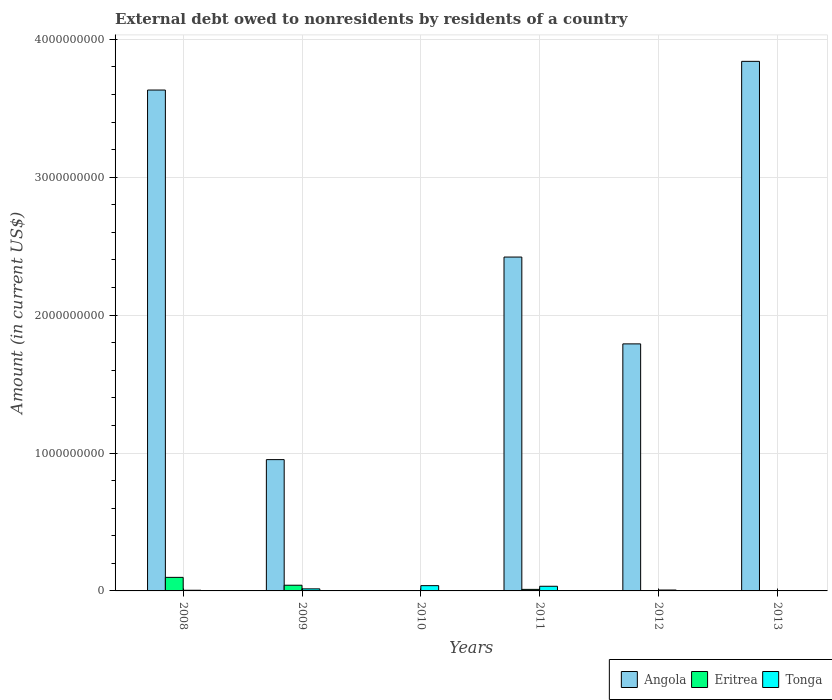Are the number of bars per tick equal to the number of legend labels?
Provide a succinct answer. No. Are the number of bars on each tick of the X-axis equal?
Give a very brief answer. No. How many bars are there on the 3rd tick from the right?
Provide a short and direct response. 3. What is the external debt owed by residents in Eritrea in 2008?
Keep it short and to the point. 9.83e+07. Across all years, what is the maximum external debt owed by residents in Tonga?
Keep it short and to the point. 3.82e+07. Across all years, what is the minimum external debt owed by residents in Tonga?
Keep it short and to the point. 0. In which year was the external debt owed by residents in Eritrea maximum?
Provide a succinct answer. 2008. What is the total external debt owed by residents in Eritrea in the graph?
Provide a succinct answer. 1.51e+08. What is the difference between the external debt owed by residents in Eritrea in 2009 and that in 2011?
Ensure brevity in your answer.  3.02e+07. What is the difference between the external debt owed by residents in Eritrea in 2012 and the external debt owed by residents in Angola in 2013?
Make the answer very short. -3.84e+09. What is the average external debt owed by residents in Angola per year?
Offer a very short reply. 2.11e+09. In the year 2008, what is the difference between the external debt owed by residents in Angola and external debt owed by residents in Eritrea?
Give a very brief answer. 3.53e+09. In how many years, is the external debt owed by residents in Tonga greater than 2000000000 US$?
Offer a terse response. 0. What is the ratio of the external debt owed by residents in Angola in 2009 to that in 2013?
Make the answer very short. 0.25. Is the external debt owed by residents in Tonga in 2009 less than that in 2011?
Your response must be concise. Yes. What is the difference between the highest and the second highest external debt owed by residents in Tonga?
Provide a short and direct response. 4.60e+06. What is the difference between the highest and the lowest external debt owed by residents in Eritrea?
Provide a succinct answer. 9.83e+07. In how many years, is the external debt owed by residents in Eritrea greater than the average external debt owed by residents in Eritrea taken over all years?
Offer a very short reply. 2. Is the sum of the external debt owed by residents in Tonga in 2010 and 2011 greater than the maximum external debt owed by residents in Angola across all years?
Ensure brevity in your answer.  No. Is it the case that in every year, the sum of the external debt owed by residents in Tonga and external debt owed by residents in Eritrea is greater than the external debt owed by residents in Angola?
Make the answer very short. No. How many bars are there?
Keep it short and to the point. 13. Are all the bars in the graph horizontal?
Your answer should be very brief. No. How many years are there in the graph?
Give a very brief answer. 6. How many legend labels are there?
Ensure brevity in your answer.  3. How are the legend labels stacked?
Provide a short and direct response. Horizontal. What is the title of the graph?
Offer a very short reply. External debt owed to nonresidents by residents of a country. Does "Armenia" appear as one of the legend labels in the graph?
Your answer should be compact. No. What is the label or title of the Y-axis?
Offer a terse response. Amount (in current US$). What is the Amount (in current US$) in Angola in 2008?
Keep it short and to the point. 3.63e+09. What is the Amount (in current US$) of Eritrea in 2008?
Ensure brevity in your answer.  9.83e+07. What is the Amount (in current US$) of Tonga in 2008?
Offer a terse response. 4.80e+06. What is the Amount (in current US$) in Angola in 2009?
Give a very brief answer. 9.52e+08. What is the Amount (in current US$) of Eritrea in 2009?
Ensure brevity in your answer.  4.13e+07. What is the Amount (in current US$) in Tonga in 2009?
Ensure brevity in your answer.  1.49e+07. What is the Amount (in current US$) of Angola in 2010?
Your answer should be compact. 0. What is the Amount (in current US$) in Eritrea in 2010?
Keep it short and to the point. 0. What is the Amount (in current US$) in Tonga in 2010?
Give a very brief answer. 3.82e+07. What is the Amount (in current US$) in Angola in 2011?
Keep it short and to the point. 2.42e+09. What is the Amount (in current US$) in Eritrea in 2011?
Give a very brief answer. 1.12e+07. What is the Amount (in current US$) of Tonga in 2011?
Offer a very short reply. 3.36e+07. What is the Amount (in current US$) in Angola in 2012?
Your answer should be compact. 1.79e+09. What is the Amount (in current US$) in Tonga in 2012?
Give a very brief answer. 6.46e+06. What is the Amount (in current US$) in Angola in 2013?
Offer a terse response. 3.84e+09. Across all years, what is the maximum Amount (in current US$) of Angola?
Keep it short and to the point. 3.84e+09. Across all years, what is the maximum Amount (in current US$) of Eritrea?
Offer a terse response. 9.83e+07. Across all years, what is the maximum Amount (in current US$) of Tonga?
Provide a short and direct response. 3.82e+07. Across all years, what is the minimum Amount (in current US$) of Angola?
Provide a short and direct response. 0. Across all years, what is the minimum Amount (in current US$) in Eritrea?
Offer a very short reply. 0. What is the total Amount (in current US$) in Angola in the graph?
Offer a very short reply. 1.26e+1. What is the total Amount (in current US$) of Eritrea in the graph?
Ensure brevity in your answer.  1.51e+08. What is the total Amount (in current US$) in Tonga in the graph?
Offer a very short reply. 9.81e+07. What is the difference between the Amount (in current US$) in Angola in 2008 and that in 2009?
Provide a succinct answer. 2.68e+09. What is the difference between the Amount (in current US$) of Eritrea in 2008 and that in 2009?
Provide a short and direct response. 5.70e+07. What is the difference between the Amount (in current US$) of Tonga in 2008 and that in 2009?
Your response must be concise. -1.02e+07. What is the difference between the Amount (in current US$) of Tonga in 2008 and that in 2010?
Make the answer very short. -3.34e+07. What is the difference between the Amount (in current US$) in Angola in 2008 and that in 2011?
Make the answer very short. 1.21e+09. What is the difference between the Amount (in current US$) of Eritrea in 2008 and that in 2011?
Your answer should be compact. 8.72e+07. What is the difference between the Amount (in current US$) of Tonga in 2008 and that in 2011?
Offer a very short reply. -2.89e+07. What is the difference between the Amount (in current US$) in Angola in 2008 and that in 2012?
Your answer should be compact. 1.84e+09. What is the difference between the Amount (in current US$) in Tonga in 2008 and that in 2012?
Provide a succinct answer. -1.66e+06. What is the difference between the Amount (in current US$) in Angola in 2008 and that in 2013?
Offer a terse response. -2.08e+08. What is the difference between the Amount (in current US$) in Tonga in 2009 and that in 2010?
Provide a short and direct response. -2.33e+07. What is the difference between the Amount (in current US$) in Angola in 2009 and that in 2011?
Your answer should be very brief. -1.47e+09. What is the difference between the Amount (in current US$) in Eritrea in 2009 and that in 2011?
Offer a very short reply. 3.02e+07. What is the difference between the Amount (in current US$) of Tonga in 2009 and that in 2011?
Ensure brevity in your answer.  -1.87e+07. What is the difference between the Amount (in current US$) in Angola in 2009 and that in 2012?
Provide a succinct answer. -8.39e+08. What is the difference between the Amount (in current US$) in Tonga in 2009 and that in 2012?
Provide a succinct answer. 8.49e+06. What is the difference between the Amount (in current US$) of Angola in 2009 and that in 2013?
Offer a terse response. -2.89e+09. What is the difference between the Amount (in current US$) of Tonga in 2010 and that in 2011?
Make the answer very short. 4.60e+06. What is the difference between the Amount (in current US$) in Tonga in 2010 and that in 2012?
Ensure brevity in your answer.  3.18e+07. What is the difference between the Amount (in current US$) of Angola in 2011 and that in 2012?
Your answer should be very brief. 6.30e+08. What is the difference between the Amount (in current US$) of Tonga in 2011 and that in 2012?
Provide a short and direct response. 2.72e+07. What is the difference between the Amount (in current US$) of Angola in 2011 and that in 2013?
Ensure brevity in your answer.  -1.42e+09. What is the difference between the Amount (in current US$) in Angola in 2012 and that in 2013?
Provide a short and direct response. -2.05e+09. What is the difference between the Amount (in current US$) in Angola in 2008 and the Amount (in current US$) in Eritrea in 2009?
Provide a short and direct response. 3.59e+09. What is the difference between the Amount (in current US$) in Angola in 2008 and the Amount (in current US$) in Tonga in 2009?
Give a very brief answer. 3.62e+09. What is the difference between the Amount (in current US$) in Eritrea in 2008 and the Amount (in current US$) in Tonga in 2009?
Your response must be concise. 8.34e+07. What is the difference between the Amount (in current US$) of Angola in 2008 and the Amount (in current US$) of Tonga in 2010?
Offer a terse response. 3.59e+09. What is the difference between the Amount (in current US$) in Eritrea in 2008 and the Amount (in current US$) in Tonga in 2010?
Give a very brief answer. 6.01e+07. What is the difference between the Amount (in current US$) of Angola in 2008 and the Amount (in current US$) of Eritrea in 2011?
Make the answer very short. 3.62e+09. What is the difference between the Amount (in current US$) of Angola in 2008 and the Amount (in current US$) of Tonga in 2011?
Provide a short and direct response. 3.60e+09. What is the difference between the Amount (in current US$) of Eritrea in 2008 and the Amount (in current US$) of Tonga in 2011?
Offer a very short reply. 6.47e+07. What is the difference between the Amount (in current US$) of Angola in 2008 and the Amount (in current US$) of Tonga in 2012?
Offer a terse response. 3.63e+09. What is the difference between the Amount (in current US$) of Eritrea in 2008 and the Amount (in current US$) of Tonga in 2012?
Offer a very short reply. 9.19e+07. What is the difference between the Amount (in current US$) in Angola in 2009 and the Amount (in current US$) in Tonga in 2010?
Ensure brevity in your answer.  9.14e+08. What is the difference between the Amount (in current US$) of Eritrea in 2009 and the Amount (in current US$) of Tonga in 2010?
Make the answer very short. 3.09e+06. What is the difference between the Amount (in current US$) of Angola in 2009 and the Amount (in current US$) of Eritrea in 2011?
Your answer should be compact. 9.41e+08. What is the difference between the Amount (in current US$) in Angola in 2009 and the Amount (in current US$) in Tonga in 2011?
Make the answer very short. 9.18e+08. What is the difference between the Amount (in current US$) in Eritrea in 2009 and the Amount (in current US$) in Tonga in 2011?
Your response must be concise. 7.68e+06. What is the difference between the Amount (in current US$) in Angola in 2009 and the Amount (in current US$) in Tonga in 2012?
Provide a short and direct response. 9.46e+08. What is the difference between the Amount (in current US$) of Eritrea in 2009 and the Amount (in current US$) of Tonga in 2012?
Provide a short and direct response. 3.49e+07. What is the difference between the Amount (in current US$) in Angola in 2011 and the Amount (in current US$) in Tonga in 2012?
Offer a terse response. 2.41e+09. What is the difference between the Amount (in current US$) of Eritrea in 2011 and the Amount (in current US$) of Tonga in 2012?
Give a very brief answer. 4.70e+06. What is the average Amount (in current US$) of Angola per year?
Provide a short and direct response. 2.11e+09. What is the average Amount (in current US$) in Eritrea per year?
Your answer should be very brief. 2.51e+07. What is the average Amount (in current US$) of Tonga per year?
Provide a succinct answer. 1.63e+07. In the year 2008, what is the difference between the Amount (in current US$) of Angola and Amount (in current US$) of Eritrea?
Keep it short and to the point. 3.53e+09. In the year 2008, what is the difference between the Amount (in current US$) in Angola and Amount (in current US$) in Tonga?
Provide a succinct answer. 3.63e+09. In the year 2008, what is the difference between the Amount (in current US$) of Eritrea and Amount (in current US$) of Tonga?
Provide a succinct answer. 9.35e+07. In the year 2009, what is the difference between the Amount (in current US$) in Angola and Amount (in current US$) in Eritrea?
Your response must be concise. 9.11e+08. In the year 2009, what is the difference between the Amount (in current US$) of Angola and Amount (in current US$) of Tonga?
Keep it short and to the point. 9.37e+08. In the year 2009, what is the difference between the Amount (in current US$) of Eritrea and Amount (in current US$) of Tonga?
Provide a succinct answer. 2.64e+07. In the year 2011, what is the difference between the Amount (in current US$) of Angola and Amount (in current US$) of Eritrea?
Your response must be concise. 2.41e+09. In the year 2011, what is the difference between the Amount (in current US$) in Angola and Amount (in current US$) in Tonga?
Provide a short and direct response. 2.39e+09. In the year 2011, what is the difference between the Amount (in current US$) in Eritrea and Amount (in current US$) in Tonga?
Provide a succinct answer. -2.25e+07. In the year 2012, what is the difference between the Amount (in current US$) of Angola and Amount (in current US$) of Tonga?
Your answer should be very brief. 1.78e+09. What is the ratio of the Amount (in current US$) of Angola in 2008 to that in 2009?
Provide a short and direct response. 3.81. What is the ratio of the Amount (in current US$) of Eritrea in 2008 to that in 2009?
Offer a very short reply. 2.38. What is the ratio of the Amount (in current US$) in Tonga in 2008 to that in 2009?
Keep it short and to the point. 0.32. What is the ratio of the Amount (in current US$) of Tonga in 2008 to that in 2010?
Offer a very short reply. 0.13. What is the ratio of the Amount (in current US$) of Angola in 2008 to that in 2011?
Offer a terse response. 1.5. What is the ratio of the Amount (in current US$) of Eritrea in 2008 to that in 2011?
Ensure brevity in your answer.  8.82. What is the ratio of the Amount (in current US$) in Tonga in 2008 to that in 2011?
Provide a short and direct response. 0.14. What is the ratio of the Amount (in current US$) of Angola in 2008 to that in 2012?
Keep it short and to the point. 2.03. What is the ratio of the Amount (in current US$) of Tonga in 2008 to that in 2012?
Ensure brevity in your answer.  0.74. What is the ratio of the Amount (in current US$) in Angola in 2008 to that in 2013?
Provide a succinct answer. 0.95. What is the ratio of the Amount (in current US$) of Tonga in 2009 to that in 2010?
Your answer should be compact. 0.39. What is the ratio of the Amount (in current US$) of Angola in 2009 to that in 2011?
Keep it short and to the point. 0.39. What is the ratio of the Amount (in current US$) of Eritrea in 2009 to that in 2011?
Ensure brevity in your answer.  3.71. What is the ratio of the Amount (in current US$) in Tonga in 2009 to that in 2011?
Ensure brevity in your answer.  0.44. What is the ratio of the Amount (in current US$) in Angola in 2009 to that in 2012?
Provide a short and direct response. 0.53. What is the ratio of the Amount (in current US$) in Tonga in 2009 to that in 2012?
Keep it short and to the point. 2.31. What is the ratio of the Amount (in current US$) in Angola in 2009 to that in 2013?
Give a very brief answer. 0.25. What is the ratio of the Amount (in current US$) in Tonga in 2010 to that in 2011?
Your answer should be very brief. 1.14. What is the ratio of the Amount (in current US$) of Tonga in 2010 to that in 2012?
Ensure brevity in your answer.  5.92. What is the ratio of the Amount (in current US$) in Angola in 2011 to that in 2012?
Provide a succinct answer. 1.35. What is the ratio of the Amount (in current US$) of Tonga in 2011 to that in 2012?
Make the answer very short. 5.21. What is the ratio of the Amount (in current US$) in Angola in 2011 to that in 2013?
Give a very brief answer. 0.63. What is the ratio of the Amount (in current US$) of Angola in 2012 to that in 2013?
Your answer should be very brief. 0.47. What is the difference between the highest and the second highest Amount (in current US$) in Angola?
Your response must be concise. 2.08e+08. What is the difference between the highest and the second highest Amount (in current US$) of Eritrea?
Offer a terse response. 5.70e+07. What is the difference between the highest and the second highest Amount (in current US$) of Tonga?
Your answer should be compact. 4.60e+06. What is the difference between the highest and the lowest Amount (in current US$) in Angola?
Your response must be concise. 3.84e+09. What is the difference between the highest and the lowest Amount (in current US$) of Eritrea?
Offer a very short reply. 9.83e+07. What is the difference between the highest and the lowest Amount (in current US$) in Tonga?
Offer a very short reply. 3.82e+07. 